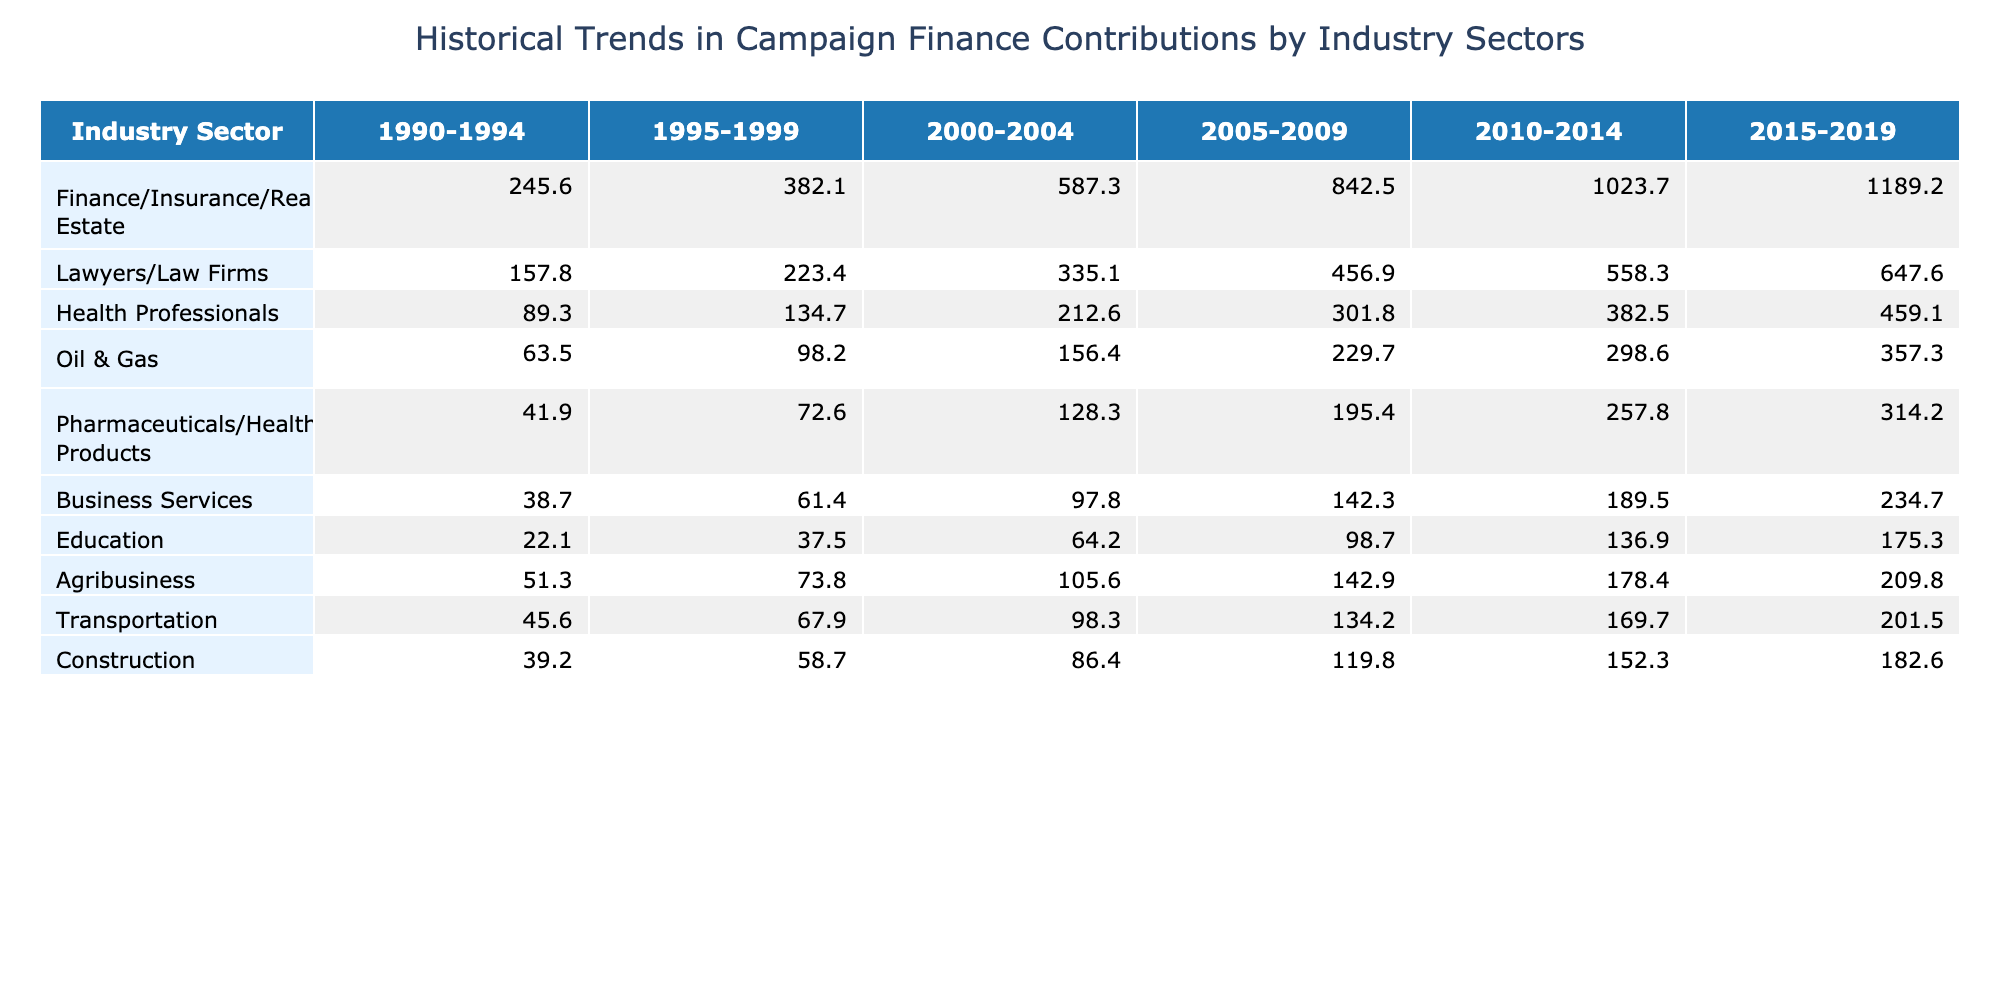What was the total contribution from the Finance/Insurance/Real Estate sector from 2010 to 2019? The contribution from this sector for these years is 1023.7 (2010-2014) + 1189.2 (2015-2019) = 2212.9.
Answer: 2212.9 Which industry sector had the highest contributions in the 1990-1994 period? By examining the first column under the 1990-1994 period, the Finance/Insurance/Real Estate sector at 245.6 had the highest contributions compared to the other sectors.
Answer: Finance/Insurance/Real Estate What is the average contribution from the Health Professionals sector over all time periods? To find the average, add all contributions from the Health Professionals sector: (89.3 + 134.7 + 212.6 + 301.8 + 382.5 + 459.1) = 1078.0. There are 6 periods, so the average is 1078.0 / 6 = 179.67.
Answer: 179.67 Did the contributions from the Oil & Gas sector increase every period? By comparing each period's contributions, we see that the values increased from 63.5 to 357.3, confirming it did increase each period.
Answer: Yes What was the difference in contributions between the Finance/Insurance/Real Estate sector and the Pharmaceuticals/Health Products sector in 2005-2009? The contribution from Finance/Insurance/Real Estate was 842.5 and from Pharmaceuticals/Health Products was 195.4; the difference is 842.5 - 195.4 = 647.1.
Answer: 647.1 Which sector showed the smallest growth in contributions from 2010-2014 to 2015-2019? The growth for each sector can be calculated by finding the difference of the contributions for 2015-2019 and 2010-2014. The smallest growth is from Education: 175.3 - 136.9 = 38.4.
Answer: Education What was the total contribution from all sectors in 2000-2004? To find the total contribution in this period, we sum the contributions from all sectors: 587.3 + 335.1 + 212.6 + 156.4 + 128.3 + 97.8 + 64.2 + 105.6 + 98.3 + 86.4 = 1850.5.
Answer: 1850.5 Between 2015 and 2019, which two sectors had the highest contributions combined? The two sectors with the highest contributions during this period are Finance/Insurance/Real Estate (1189.2) and Lawyers/Law Firms (647.6). Combined, their contributions are 1189.2 + 647.6 = 1836.8.
Answer: 1836.8 How much did the contribution from the Construction sector increase from 1990-1994 to 2015-2019? The contribution from Construction in 1990-1994 was 39.2 and in 2015-2019 was 182.6; the increase is 182.6 - 39.2 = 143.4.
Answer: 143.4 Was the contribution from the Business Services sector greater than the contribution from the Agribusiness sector in any period? Comparing the contributions in all periods shows Agribusiness had a higher contribution in 1990-1994 (51.3 vs. 38.7), but Business Services was greater in 1995-1999 (61.4 vs. 73.8). Hence, Business Services did surpass Agribusiness in several periods.
Answer: Yes 